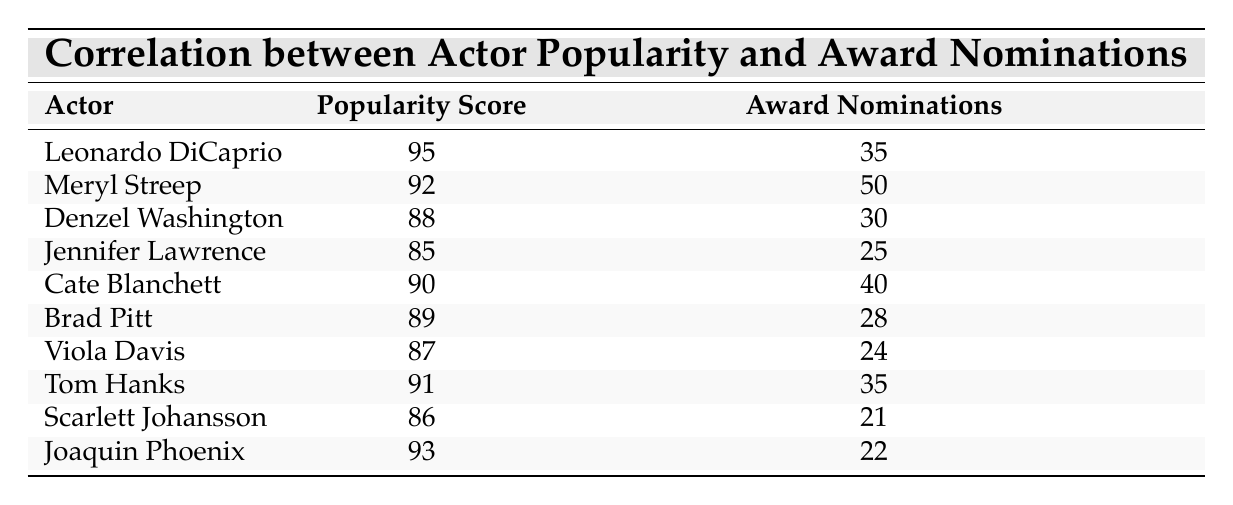What is the highest award nominations received by an actor in the table? Meryl Streep has received the highest award nominations, which is 50. This can be directly observed in the table where her nominations are listed.
Answer: 50 Which actor has the lowest popularity score and what is that score? Scarlett Johansson has the lowest popularity score of 86. This can be found by comparing the popularity scores of all listed actors.
Answer: 86 Is there an actor who has a popularity score above 90 and also has more than 30 award nominations? Yes, both Leonardo DiCaprio (popularity 95, nominations 35) and Tom Hanks (popularity 91, nominations 35) meet this criterion. This requires checking both the popularity score and nominations together.
Answer: Yes What is the average award nominations of the actors listed in the table? To find the average, sum up all award nominations: 35 + 50 + 30 + 25 + 40 + 28 + 24 + 35 + 21 + 22 =  307. There are 10 actors, so divide by 10: 307/10 = 30.7.
Answer: 30.7 Which actor has a popularity score between 85 and 90 and what is their award nominations? Two actors fall within this range: Jennifer Lawrence (popularity 85, nominations 25) and Brad Pitt (popularity 89, nominations 28). This involves filtering the table for actors that meet the popularity score condition.
Answer: Jennifer Lawrence (25), Brad Pitt (28) Which actor is more popular: Denzel Washington or Jennifer Lawrence? Denzel Washington has a popularity score of 88, while Jennifer Lawrence has a score of 85. Therefore, Denzel Washington is more popular. This can be seen by comparing their respective scores in the table.
Answer: Denzel Washington What is the difference in award nominations between Meryl Streep and Cate Blanchett? Meryl Streep has 50 nominations and Cate Blanchett has 40 nominations. Thus, the difference is 50 - 40 = 10. This involved checking their nomination counts.
Answer: 10 Is there any actor with a popularity score lower than 85? No, all actors have a popularity score of 85 or higher. This can be validated by reviewing the scores listed in the table.
Answer: No 